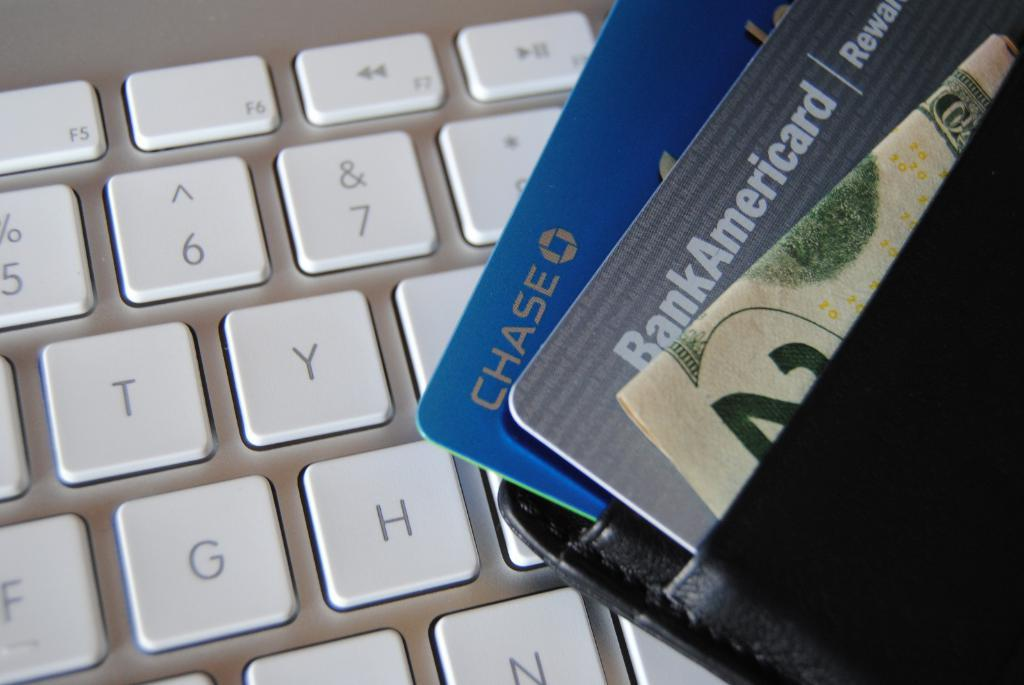<image>
Relay a brief, clear account of the picture shown. A wallet with credit cards in it from Chase and Bank of America is on a laptop keyboard. 